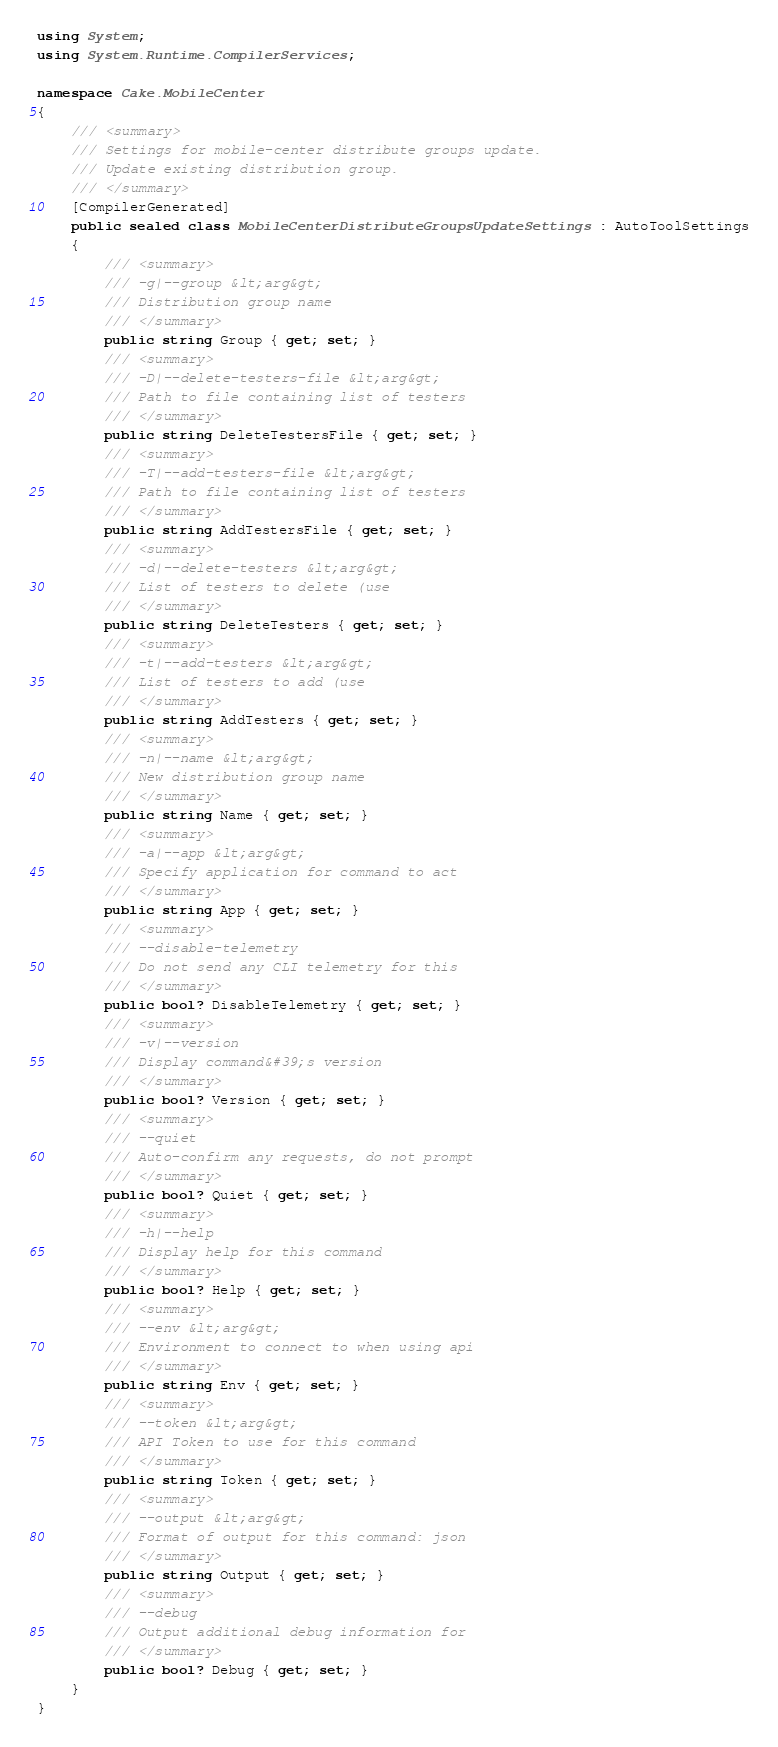<code> <loc_0><loc_0><loc_500><loc_500><_C#_>using System;
using System.Runtime.CompilerServices;

namespace Cake.MobileCenter
{
	/// <summary>
	/// Settings for mobile-center distribute groups update.
	/// Update existing distribution group.
	/// </summary>
	[CompilerGenerated]
	public sealed class MobileCenterDistributeGroupsUpdateSettings : AutoToolSettings
	{
		/// <summary>
		/// -g|--group &lt;arg&gt;
		/// Distribution group name
		/// </summary>
		public string Group { get; set; }
		/// <summary>
		/// -D|--delete-testers-file &lt;arg&gt;
		/// Path to file containing list of testers
		/// </summary>
		public string DeleteTestersFile { get; set; }
		/// <summary>
		/// -T|--add-testers-file &lt;arg&gt;
		/// Path to file containing list of testers
		/// </summary>
		public string AddTestersFile { get; set; }
		/// <summary>
		/// -d|--delete-testers &lt;arg&gt;
		/// List of testers to delete (use
		/// </summary>
		public string DeleteTesters { get; set; }
		/// <summary>
		/// -t|--add-testers &lt;arg&gt;
		/// List of testers to add (use
		/// </summary>
		public string AddTesters { get; set; }
		/// <summary>
		/// -n|--name &lt;arg&gt;
		/// New distribution group name
		/// </summary>
		public string Name { get; set; }
		/// <summary>
		/// -a|--app &lt;arg&gt;
		/// Specify application for command to act
		/// </summary>
		public string App { get; set; }
		/// <summary>
		/// --disable-telemetry
		/// Do not send any CLI telemetry for this
		/// </summary>
		public bool? DisableTelemetry { get; set; }
		/// <summary>
		/// -v|--version
		/// Display command&#39;s version
		/// </summary>
		public bool? Version { get; set; }
		/// <summary>
		/// --quiet
		/// Auto-confirm any requests, do not prompt
		/// </summary>
		public bool? Quiet { get; set; }
		/// <summary>
		/// -h|--help
		/// Display help for this command
		/// </summary>
		public bool? Help { get; set; }
		/// <summary>
		/// --env &lt;arg&gt;
		/// Environment to connect to when using api
		/// </summary>
		public string Env { get; set; }
		/// <summary>
		/// --token &lt;arg&gt;
		/// API Token to use for this command
		/// </summary>
		public string Token { get; set; }
		/// <summary>
		/// --output &lt;arg&gt;
		/// Format of output for this command: json
		/// </summary>
		public string Output { get; set; }
		/// <summary>
		/// --debug
		/// Output additional debug information for
		/// </summary>
		public bool? Debug { get; set; }
	}
}</code> 